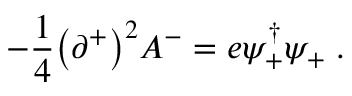<formula> <loc_0><loc_0><loc_500><loc_500>- { \frac { 1 } { 4 } } \left ( \partial ^ { + } \right ) ^ { 2 } A ^ { - } = e \psi _ { + } ^ { \dagger } \psi _ { + } \, .</formula> 